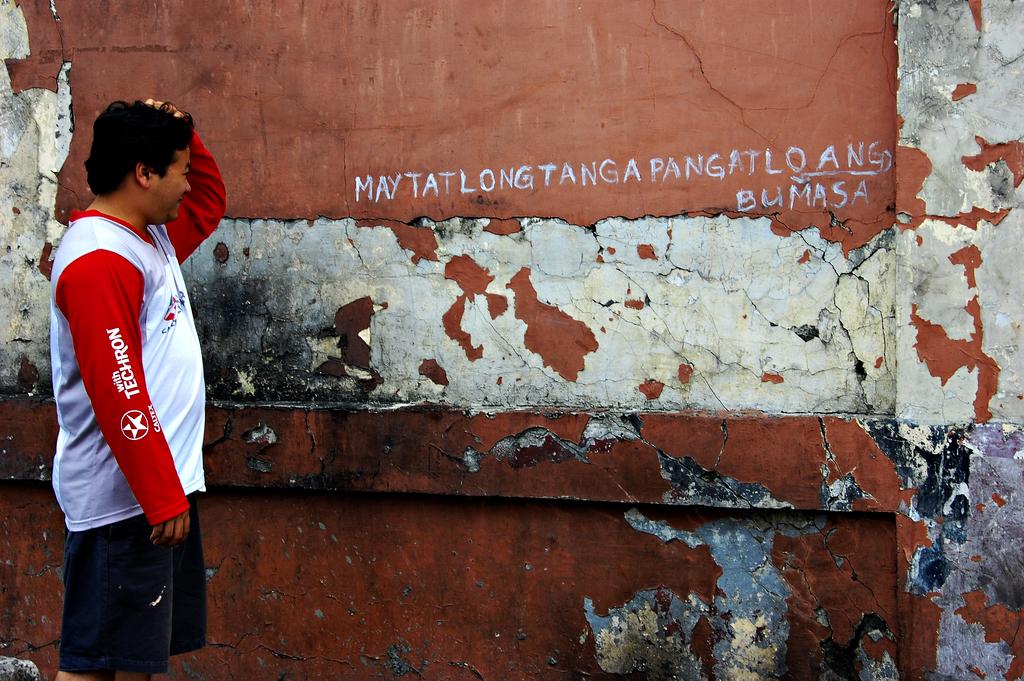What is on the mans sleeve?
Your response must be concise. Techron. 